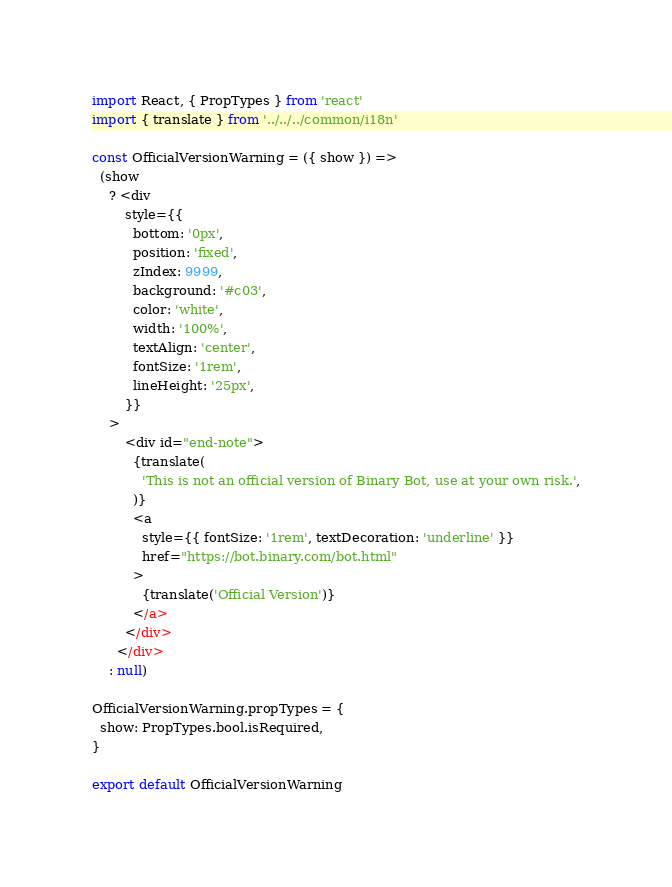<code> <loc_0><loc_0><loc_500><loc_500><_JavaScript_>import React, { PropTypes } from 'react'
import { translate } from '../../../common/i18n'

const OfficialVersionWarning = ({ show }) =>
  (show
    ? <div
        style={{
          bottom: '0px',
          position: 'fixed',
          zIndex: 9999,
          background: '#c03',
          color: 'white',
          width: '100%',
          textAlign: 'center',
          fontSize: '1rem',
          lineHeight: '25px',
        }}
    >
        <div id="end-note">
          {translate(
            'This is not an official version of Binary Bot, use at your own risk.',
          )}
          <a
            style={{ fontSize: '1rem', textDecoration: 'underline' }}
            href="https://bot.binary.com/bot.html"
          >
            {translate('Official Version')}
          </a>
        </div>
      </div>
    : null)

OfficialVersionWarning.propTypes = {
  show: PropTypes.bool.isRequired,
}

export default OfficialVersionWarning

</code> 